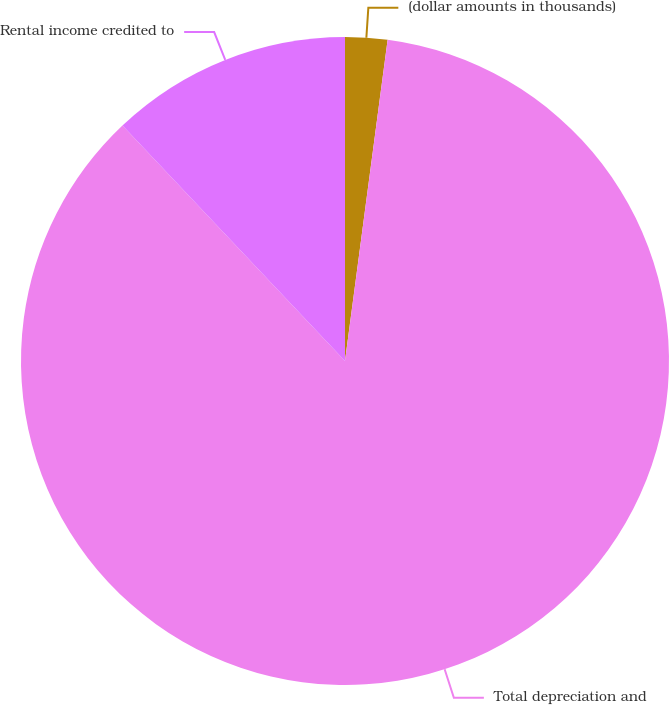Convert chart. <chart><loc_0><loc_0><loc_500><loc_500><pie_chart><fcel>(dollar amounts in thousands)<fcel>Total depreciation and<fcel>Rental income credited to<nl><fcel>2.1%<fcel>85.84%<fcel>12.05%<nl></chart> 